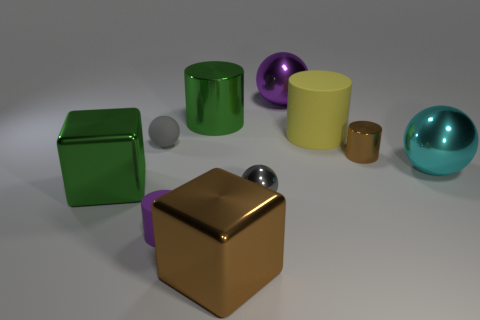How many gray balls must be subtracted to get 1 gray balls? 1 Subtract all large purple balls. How many balls are left? 3 Subtract all brown cubes. How many cubes are left? 1 Subtract all yellow cylinders. How many gray spheres are left? 2 Subtract 1 cubes. How many cubes are left? 1 Subtract all spheres. How many objects are left? 6 Subtract all tiny gray spheres. Subtract all brown blocks. How many objects are left? 7 Add 4 rubber balls. How many rubber balls are left? 5 Add 7 purple metal things. How many purple metal things exist? 8 Subtract 0 purple cubes. How many objects are left? 10 